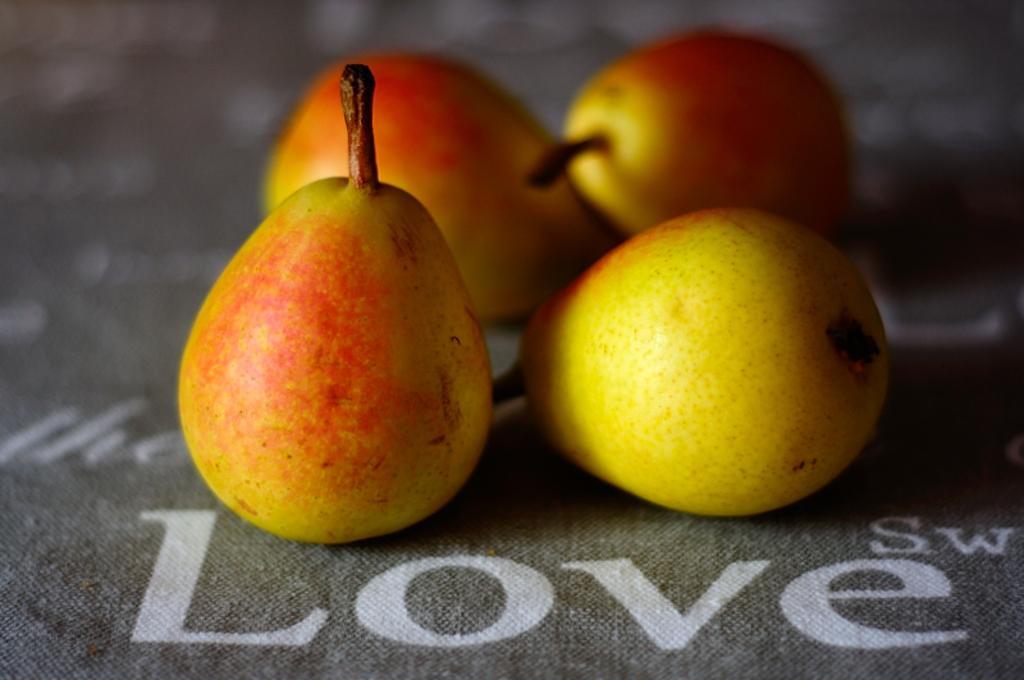Describe this image in one or two sentences. In this image there are pear fruits on a sheet. There is text on the sheet. 